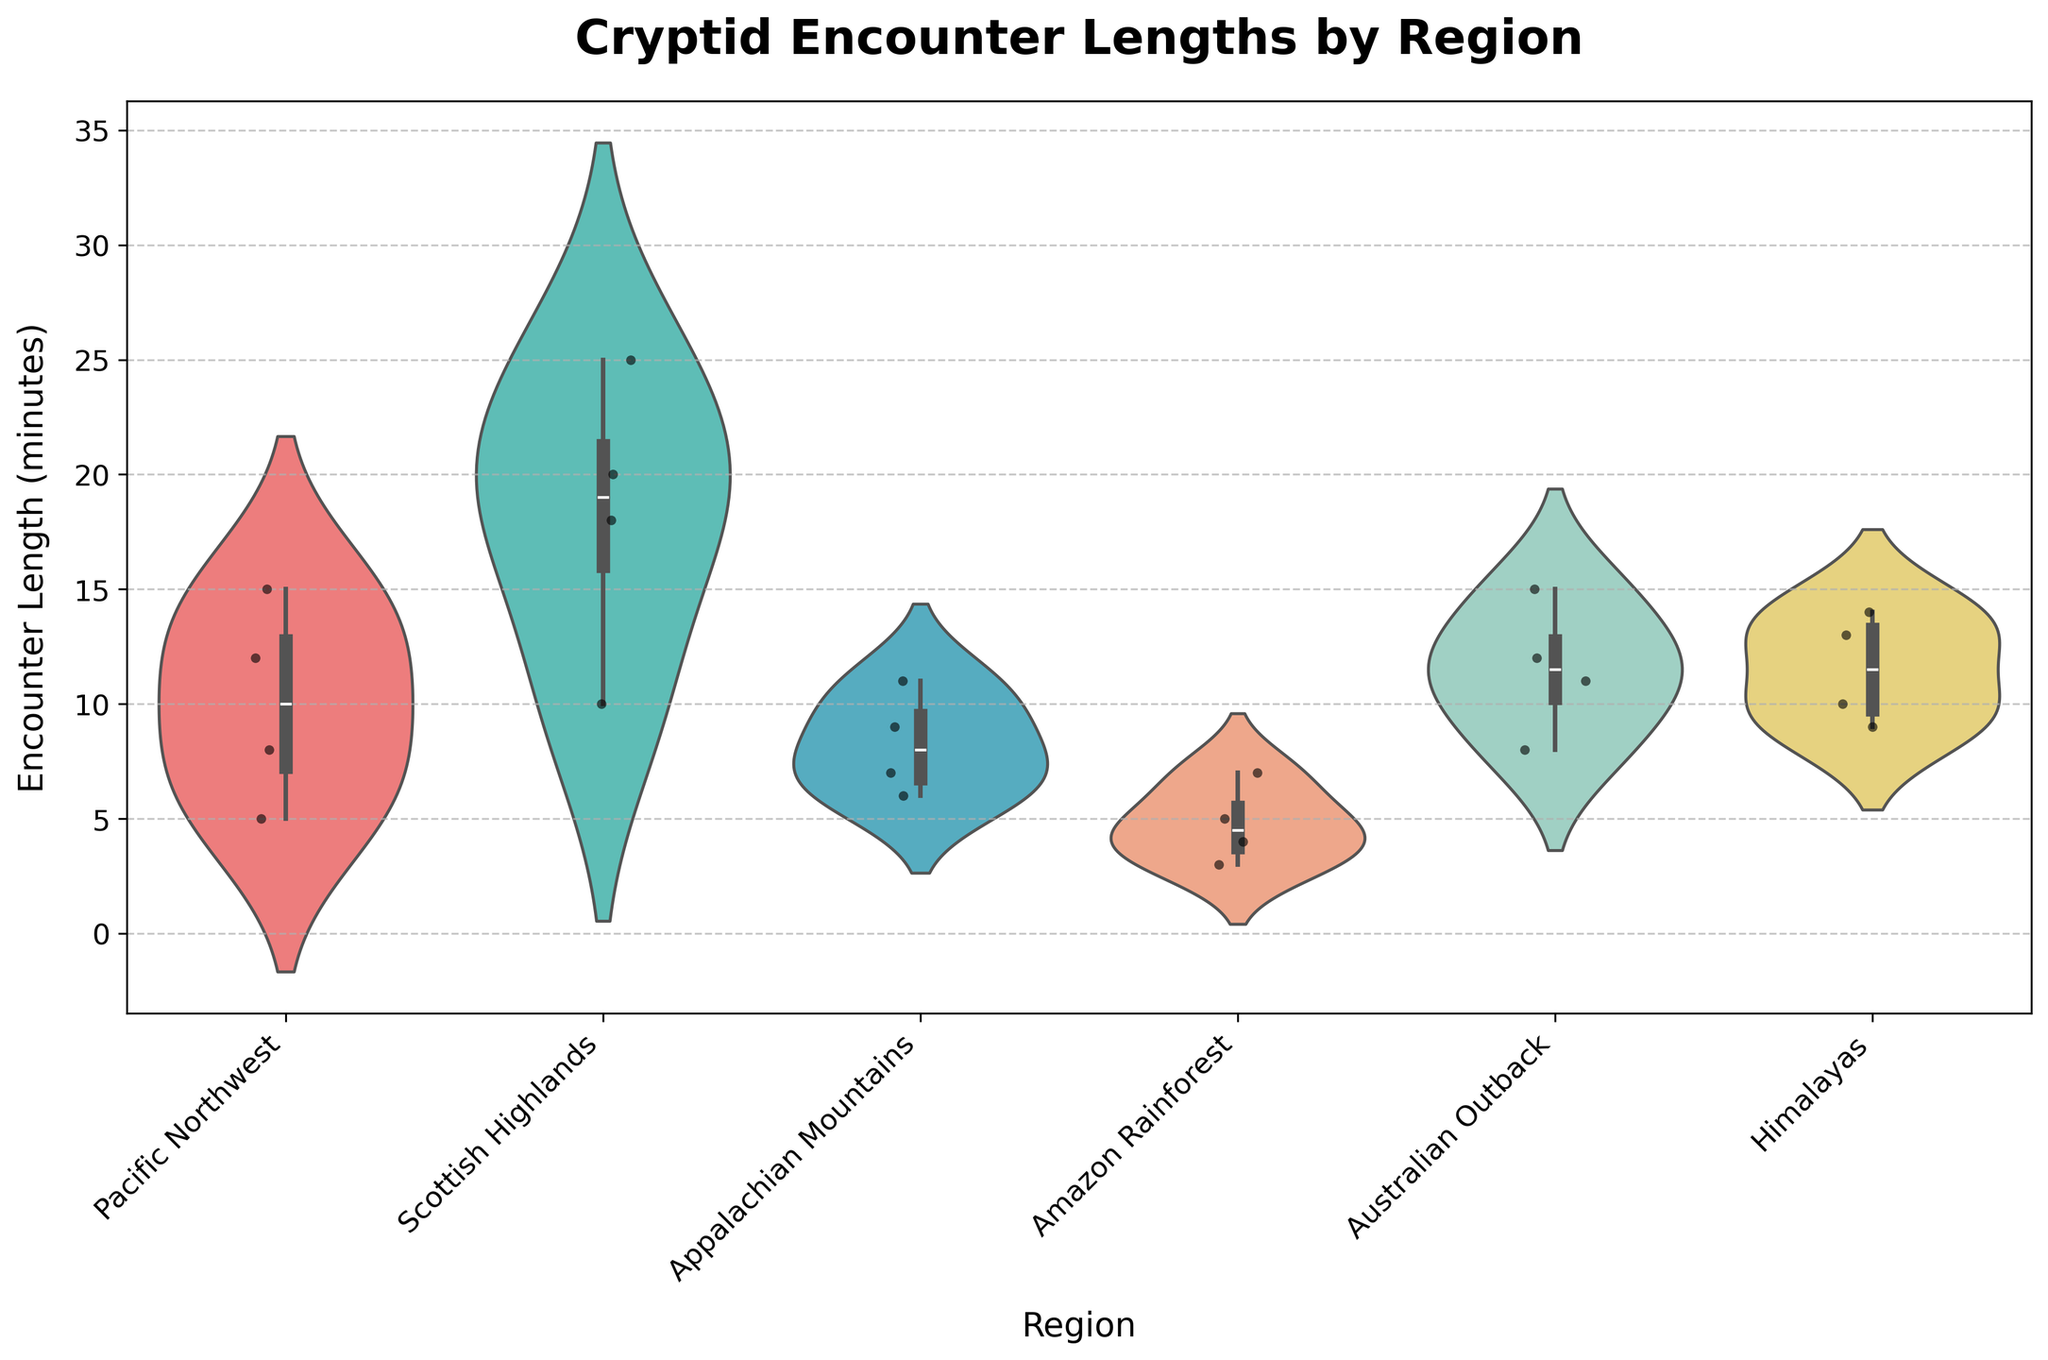What's the title of the figure? The title of the figure is prominently displayed at the top in a bold and larger font.
Answer: Cryptid Encounter Lengths by Region What is the range of encounter lengths for the Loch Ness Monster? Look at the box plot within the violin plot for the Scottish Highlands. The encounter lengths range from the lowest observed data point to the highest observed data point within that region.
Answer: 10 to 25 minutes Which region has the widest spread of encounter lengths? Identifying the region with the widest spread involves assessing the range of the distribution in each violin plot. The region with the largest spread will have the greatest distance between the minimum and maximum encounter lengths.
Answer: Scottish Highlands How do the encounter lengths for the Mothman compare to those for the Bigfoot? Compare the location and spread of the distributions for the Appalachian Mountains (Mothman) to the Pacific Northwest (Bigfoot). Look for similarities or differences in the shapes, medians, and ranges.
Answer: Mothman's encounters are shorter and more tightly clustered than Bigfoot's What is the median encounter length for the Bunyip in the Australian Outback? Locate the Australian Outback region and find the inner box plot within the violin plot. The median is represented by the horizontal line within the box.
Answer: 11.5 minutes What can be inferred about the variation in encounter lengths for the Yeti based on the violin plot? Assess the shape, width, and spread of the violin plot for the Himalayas. The distribution’s shape shows how concentrated or dispersed the encounter lengths are.
Answer: Relatively narrow spread indicates low variation In which region are the individual encounter lengths most tightly clustered? Tightly clustered points will form a dense region, which can be seen in the width of the violin plot. The violin plot for the region with the narrowest spread and most points crowding around a central value indicates tight clustering.
Answer: Amazon Rainforest Are there any regions where the encounter lengths display a bimodal distribution? Look for violin plots that display two distinct peaks or modes. Bimodal distributions will have two separate areas of higher density.
Answer: No regions display a bimodal distribution Which region has the shortest recorded cryptid encounter length, and what is it? Look for the lowest point across all jittered points in the violin plots. Identify its geographic region and corresponding value.
Answer: Amazon Rainforest, 3 minutes 